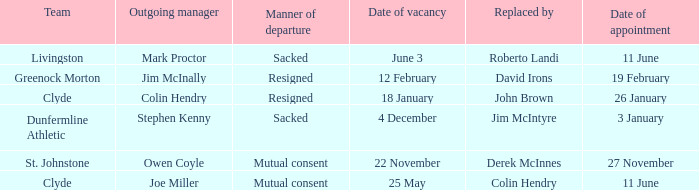Tell me the manner of departure for 3 january date of appointment Sacked. 